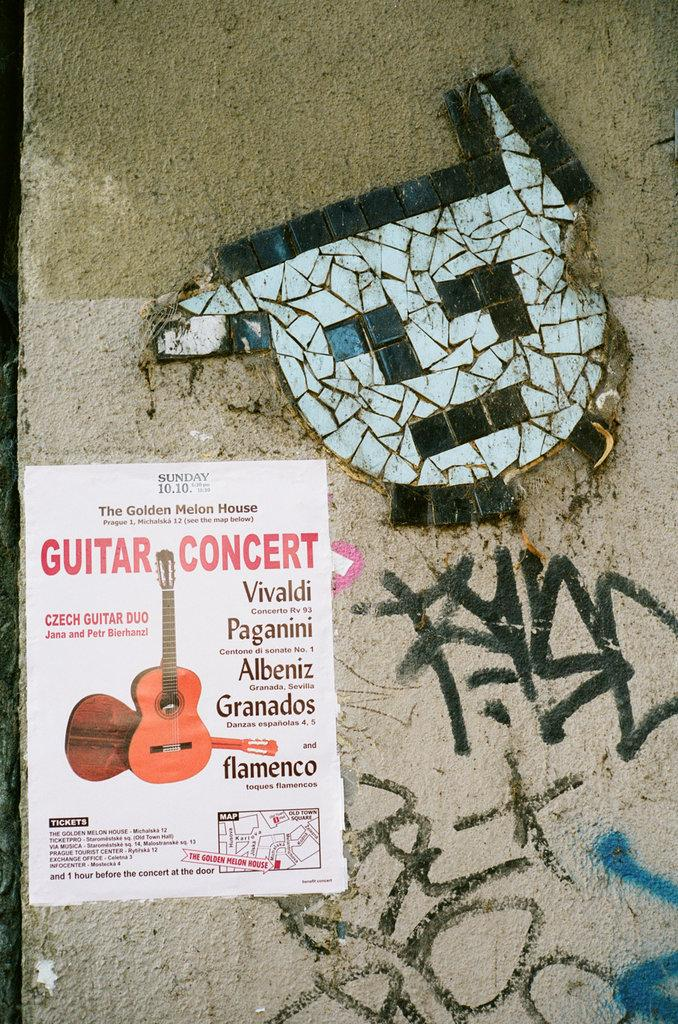<image>
Offer a succinct explanation of the picture presented. A mask on the concrete with a guitar concert poster as well. 